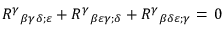Convert formula to latex. <formula><loc_0><loc_0><loc_500><loc_500>{ R ^ { \gamma } } _ { \beta \gamma \delta ; \varepsilon } + { R ^ { \gamma } } _ { \beta \varepsilon \gamma ; \delta } + { R ^ { \gamma } } _ { \beta \delta \varepsilon ; \gamma } = \, 0</formula> 